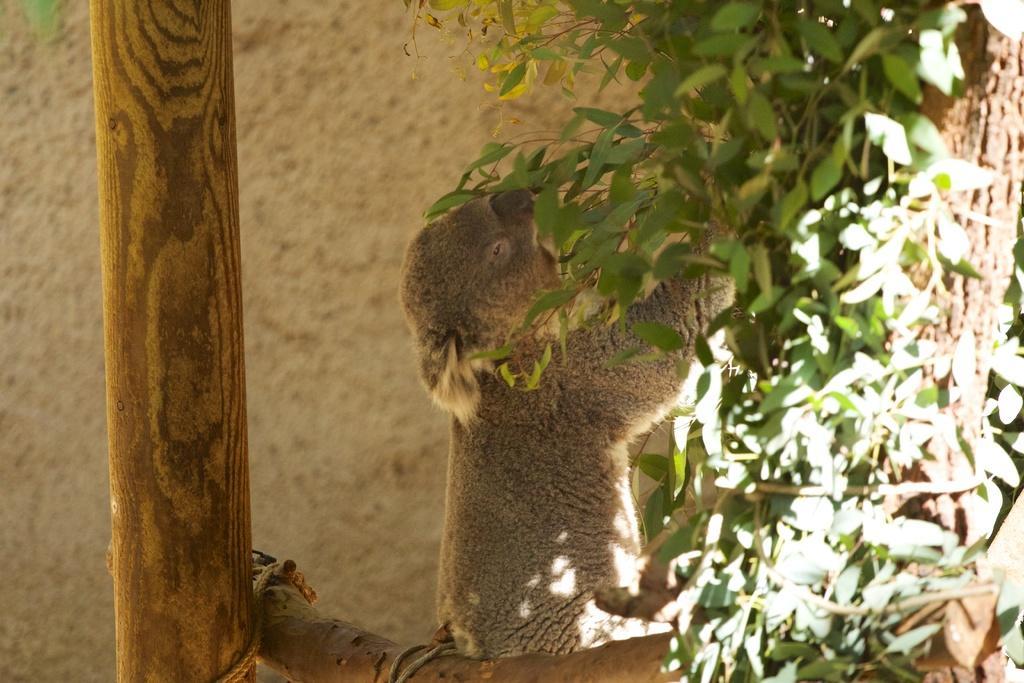Could you give a brief overview of what you see in this image? In this image we can see a koala bear sitting on the branch of a tree by holding leaves. 